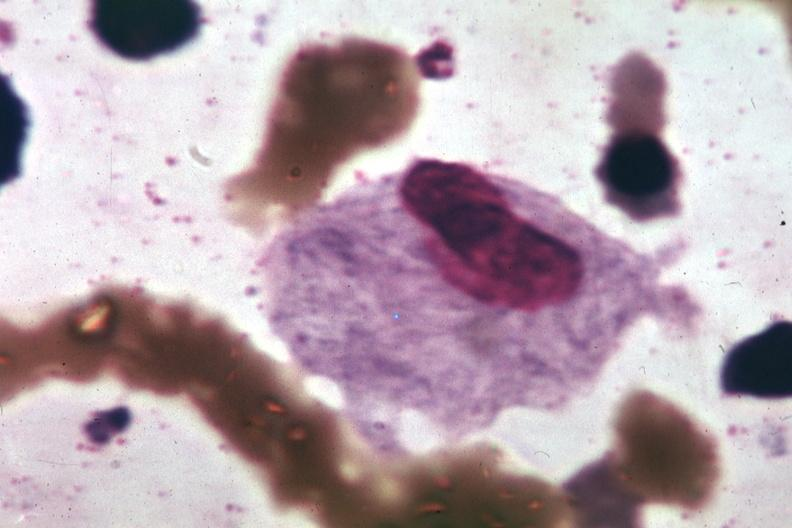what is present?
Answer the question using a single word or phrase. Bone marrow 